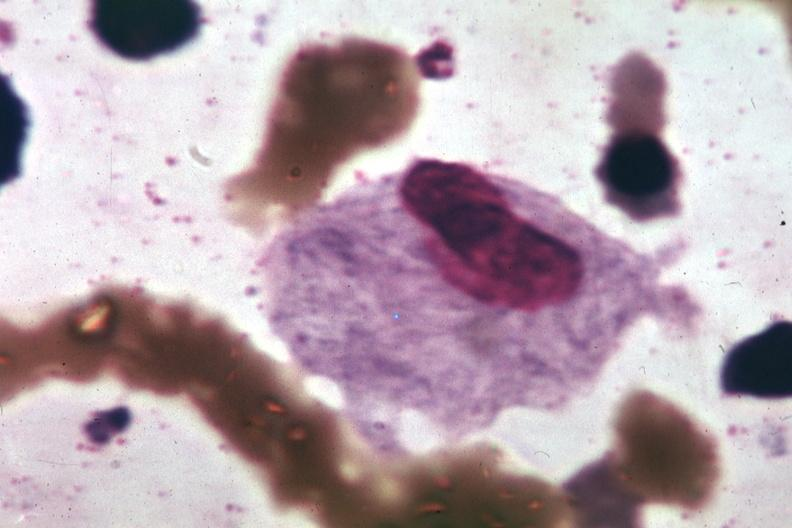what is present?
Answer the question using a single word or phrase. Bone marrow 